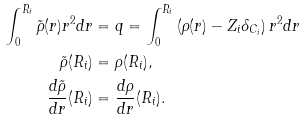<formula> <loc_0><loc_0><loc_500><loc_500>\int _ { 0 } ^ { R _ { i } } \tilde { \rho } ( r ) r ^ { 2 } d r & = q = \int _ { 0 } ^ { R _ { i } } \left ( \rho ( r ) - Z _ { i } \delta _ { C _ { i } } \right ) r ^ { 2 } d r \\ \tilde { \rho } ( R _ { i } ) & = \rho ( R _ { i } ) , \\ \frac { d \tilde { \rho } } { d r } ( R _ { i } ) & = \frac { d \rho } { d r } ( R _ { i } ) .</formula> 